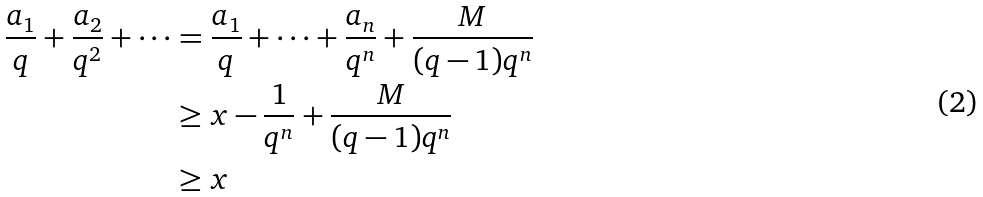<formula> <loc_0><loc_0><loc_500><loc_500>\frac { a _ { 1 } } { q } + \frac { a _ { 2 } } { q ^ { 2 } } + \cdots & = \frac { a _ { 1 } } { q } + \cdots + \frac { a _ { n } } { q ^ { n } } + \frac { M } { ( q - 1 ) q ^ { n } } \\ & \geq x - \frac { 1 } { q ^ { n } } + \frac { M } { ( q - 1 ) q ^ { n } } \\ & \geq x</formula> 